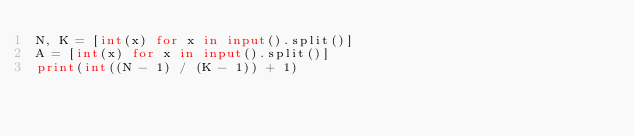Convert code to text. <code><loc_0><loc_0><loc_500><loc_500><_Python_>N, K = [int(x) for x in input().split()] 
A = [int(x) for x in input().split()]
print(int((N - 1) / (K - 1)) + 1)</code> 